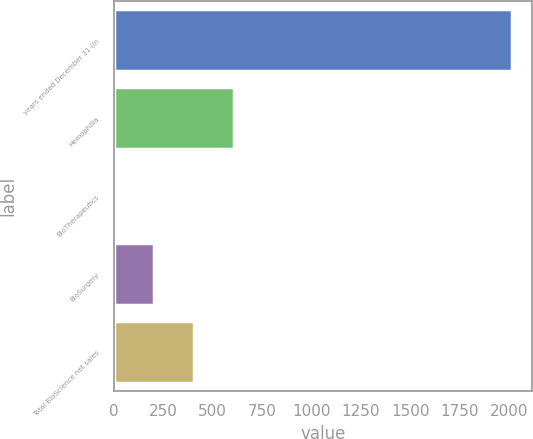Convert chart to OTSL. <chart><loc_0><loc_0><loc_500><loc_500><bar_chart><fcel>years ended December 31 (in<fcel>Hemophilia<fcel>BioTherapeutics<fcel>BioSurgery<fcel>Total BioScience net sales<nl><fcel>2013<fcel>605.3<fcel>2<fcel>203.1<fcel>404.2<nl></chart> 